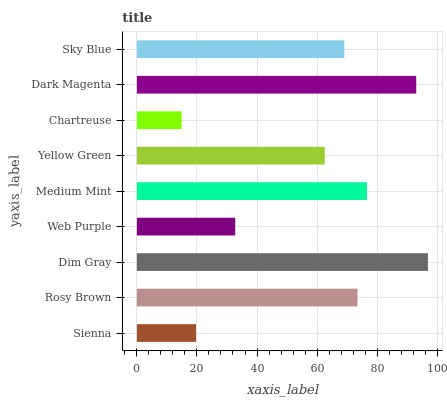Is Chartreuse the minimum?
Answer yes or no. Yes. Is Dim Gray the maximum?
Answer yes or no. Yes. Is Rosy Brown the minimum?
Answer yes or no. No. Is Rosy Brown the maximum?
Answer yes or no. No. Is Rosy Brown greater than Sienna?
Answer yes or no. Yes. Is Sienna less than Rosy Brown?
Answer yes or no. Yes. Is Sienna greater than Rosy Brown?
Answer yes or no. No. Is Rosy Brown less than Sienna?
Answer yes or no. No. Is Sky Blue the high median?
Answer yes or no. Yes. Is Sky Blue the low median?
Answer yes or no. Yes. Is Sienna the high median?
Answer yes or no. No. Is Web Purple the low median?
Answer yes or no. No. 